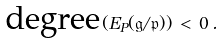<formula> <loc_0><loc_0><loc_500><loc_500>\text {degree} ( E _ { P } ( { \mathfrak g } / { \mathfrak p } ) ) \, < \, 0 \, .</formula> 